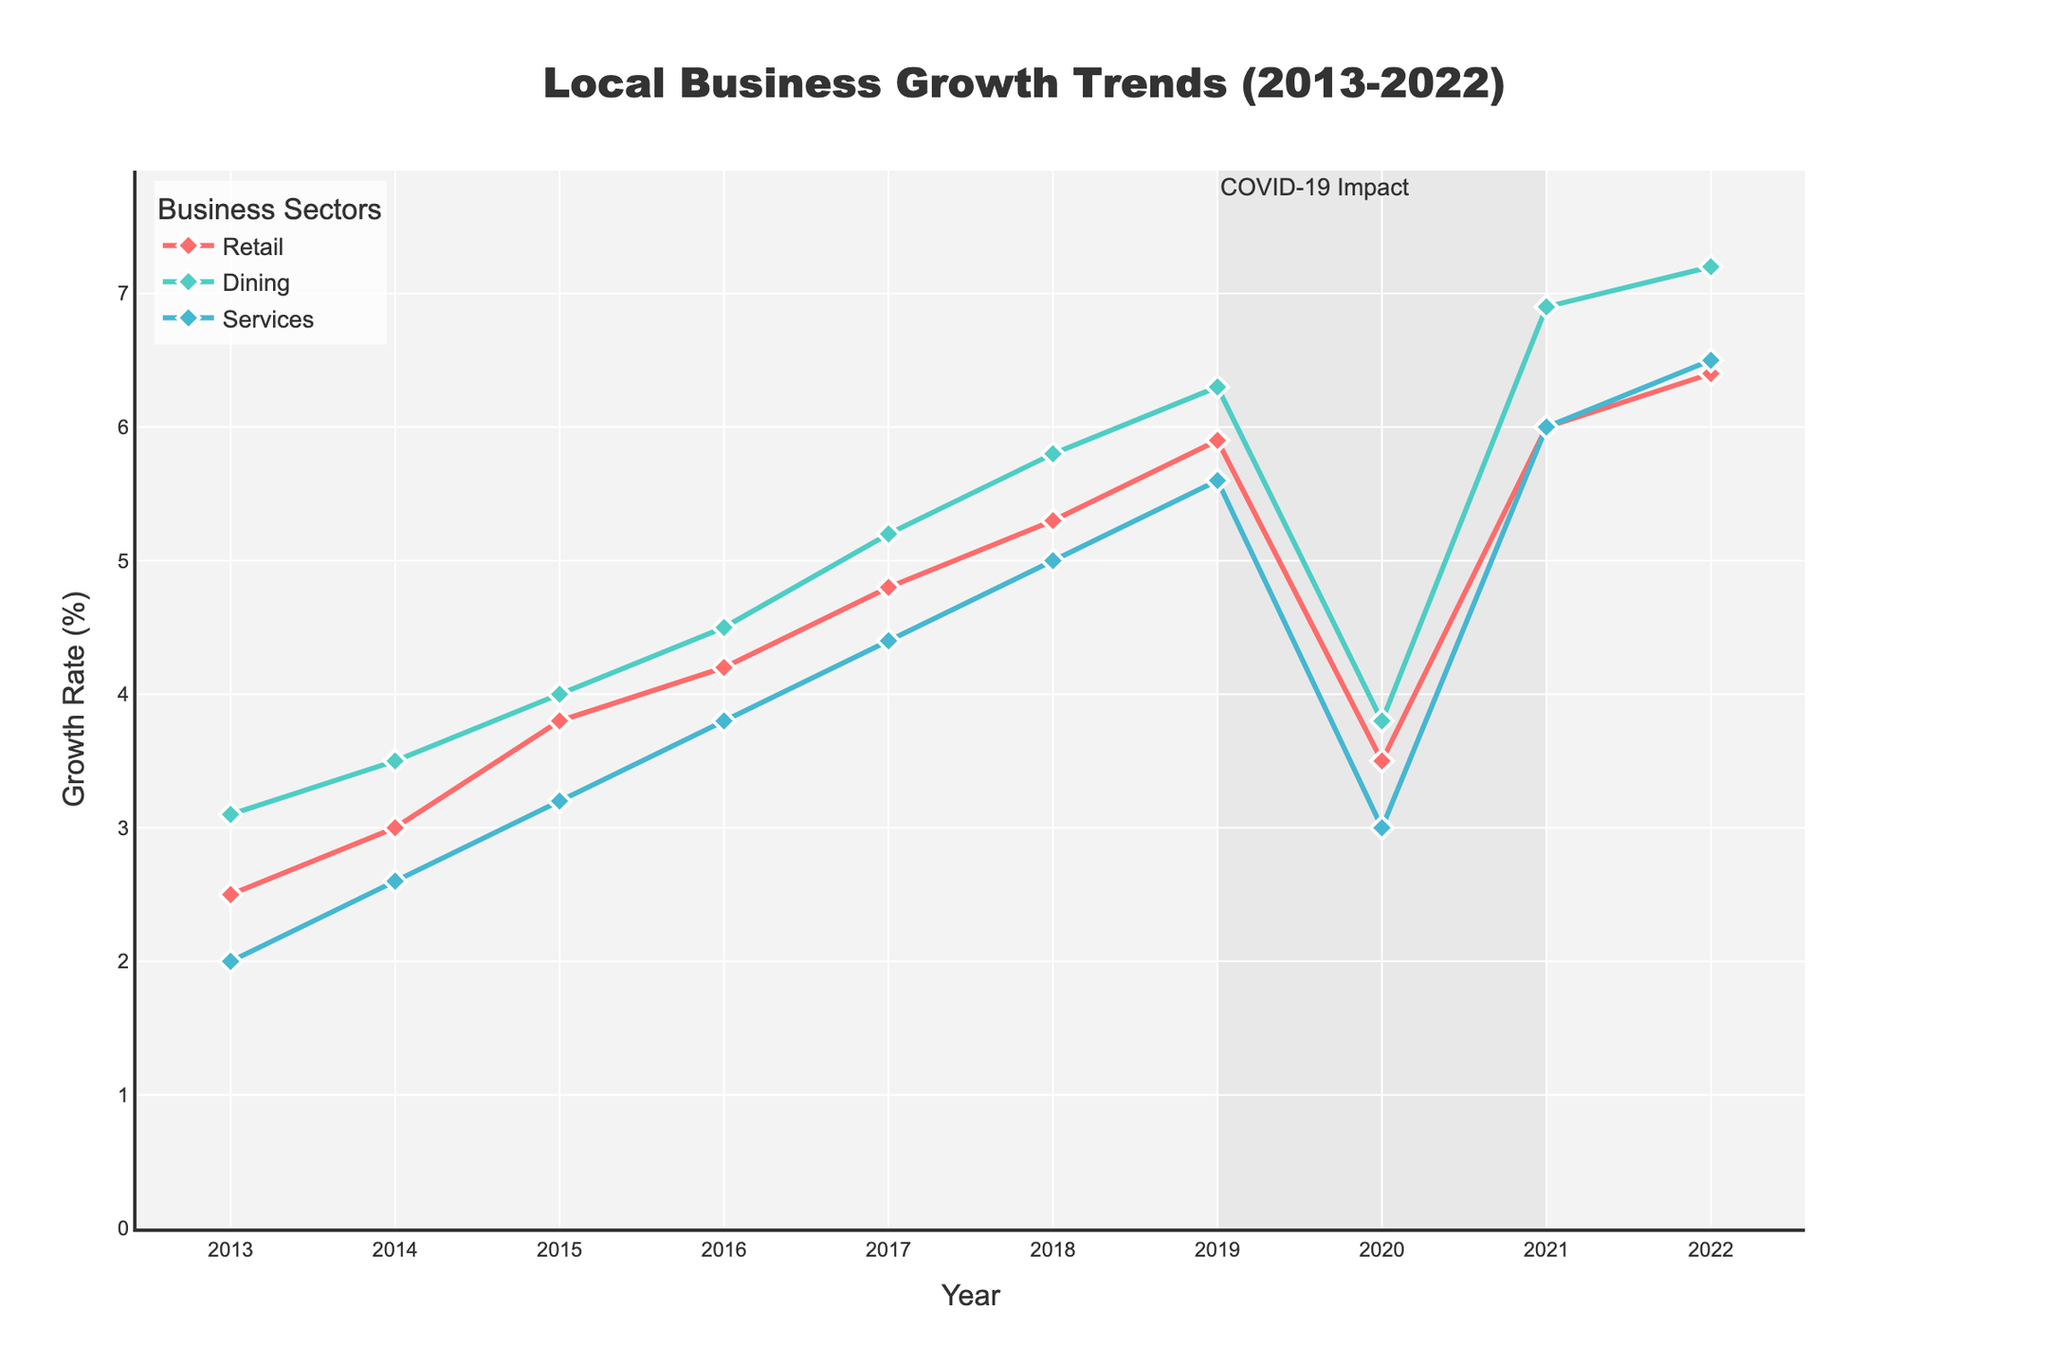What's the title of the figure? The title is clearly displayed at the top of the figure. It reads "Local Business Growth Trends (2013-2022)".
Answer: Local Business Growth Trends (2013-2022) Which business sector experienced the highest growth rate in 2022? By visually inspecting the data points for 2022, the Dining sector shows the highest growth rate compared to Retail and Services.
Answer: Dining What is the growth rate for the services sector in 2020? Locate the data point for the Services sector directly above the year 2020 on the horizontal axis. The growth rate is marked at 3.0%.
Answer: 3.0% During which years did the dining sector grow more than 6%? Trace the Dining sector trend line and identify the years when the growth rate crosses the 6% mark. This occurs in 2019, 2021, and 2022.
Answer: 2019, 2021, 2022 How did the COVID-19 impact period (2019-2021) affect the retail sector? Observe the Retail sector's trend line within the shaded area marked for COVID-19 impact, noting a drop in growth rate to 3.5% in 2020 and a significant recovery to 6% by 2021.
Answer: Decrease then recovery Which year marked the highest overall growth rate for any sector? Compare the growth rate endpoints of each sector's trend line for all years. Dining in 2022 has the highest at 7.2%.
Answer: 2022 What is the average growth rate of the Retail sector from 2013 to 2022? Sum the growth rates of the Retail sector for each year (2.5 + 3.0 + 3.8 + 4.2 + 4.8 + 5.3 + 5.9 + 3.5 + 6.0 + 6.4) and then divide by the number of years (10).
Answer: 4.54% Compare the growth rate trends between Retail and Services from 2017 to 2019. Examine the trend lines of both sectors within the specified years. Retail rose from 4.8% to 5.9%, while Services increased from 4.4% to 5.6%. Both show an upward trend, with Retail having a greater increase.
Answer: Both increased, Retail more What is the difference in growth rate between Retail and Dining in 2021? Find the data points for both Retail (6.0%) and Dining (6.9%) in 2021, then subtract Retail's rate from Dining's rate.
Answer: 0.9% During what period did all sectors show a synchronized growth increase? By examining trend lines, from 2014 to 2019, all sectors show parallel upward trends with significant growth.
Answer: 2014-2019 